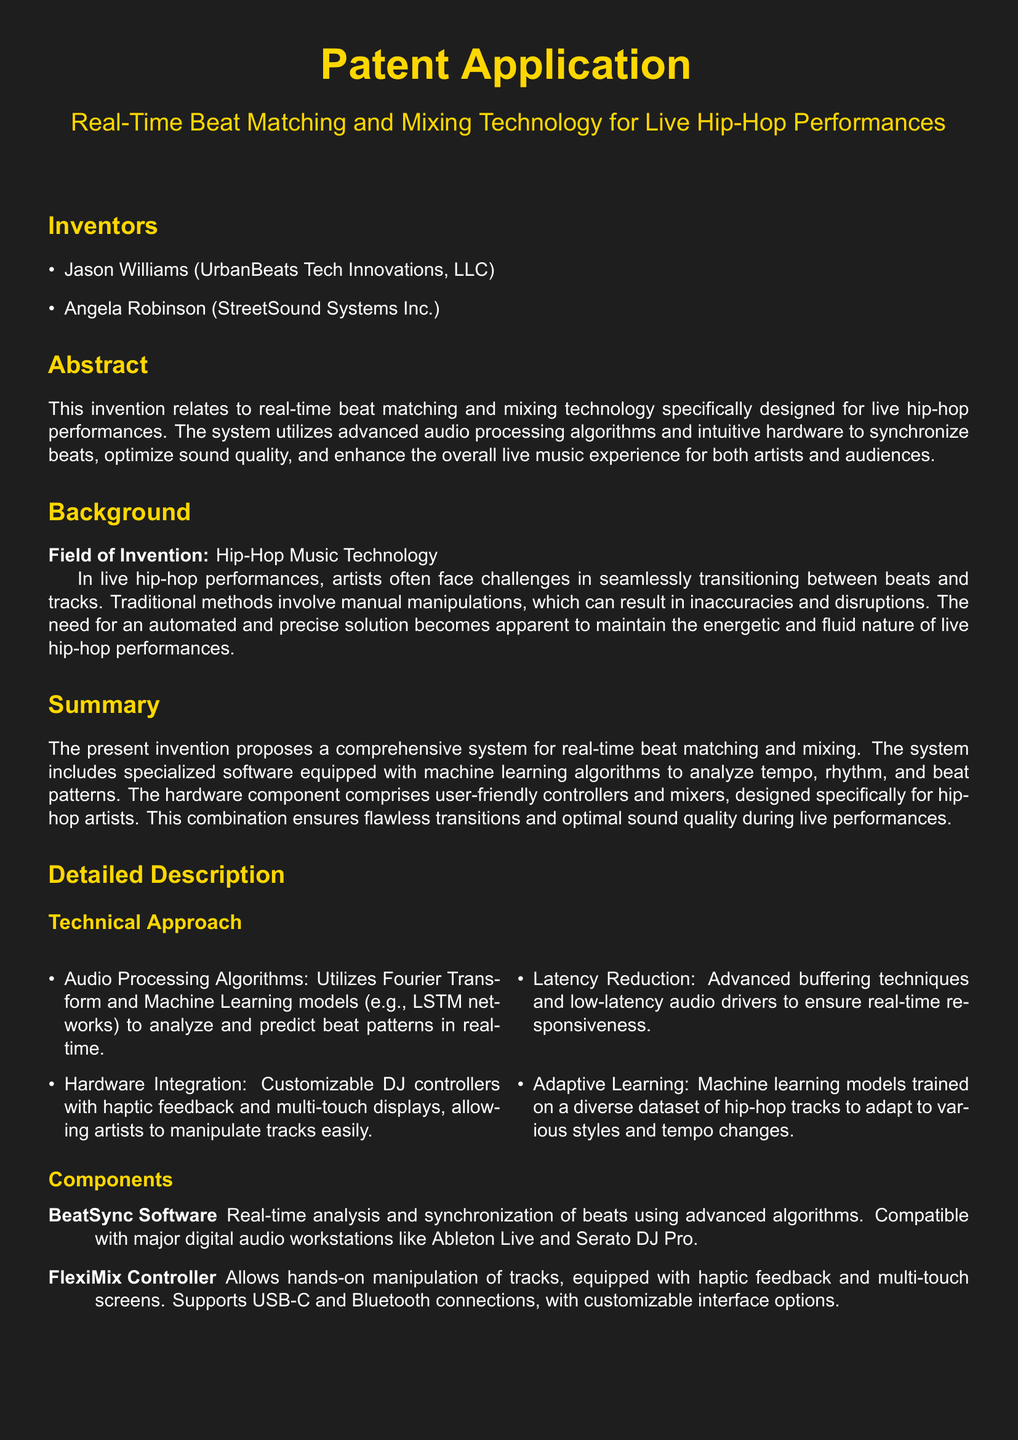What is the title of the patent application? The title of the patent application is stated clearly in the document.
Answer: Real-Time Beat Matching and Mixing Technology for Live Hip-Hop Performances Who are the inventors listed in the document? The inventors' names are provided in the section dedicated to them.
Answer: Jason Williams, Angela Robinson What type of algorithms does the BeatSync software utilize? The document mentions specific types of algorithms used for beat analysis.
Answer: Machine learning algorithms What is the name of the hardware controller mentioned in the application? The hardware controller is referred to by a specific name in the description.
Answer: FlexiMix Controller What does the technology aim to improve during live performances? The abstract outlines the primary goal of the invention in the context of live music.
Answer: The overall live music experience How does the system reduce latency? The detailed description explains the approach used to minimize audio latency.
Answer: Advanced buffering techniques What aspect of the FlexiMix Controller enhances user interaction? The document highlights a specific feature of the controller that allows for better control.
Answer: Haptic feedback What technology is the system compatible with? The summary state compatibility with known digital audio workstations.
Answer: Ableton Live, Serato DJ Pro What is the field of invention mentioned in the document? The document specifies the field under which the invention is categorized.
Answer: Hip-Hop Music Technology 